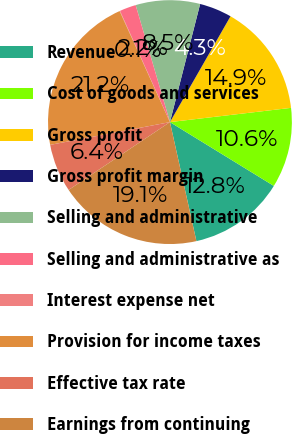Convert chart to OTSL. <chart><loc_0><loc_0><loc_500><loc_500><pie_chart><fcel>Revenue<fcel>Cost of goods and services<fcel>Gross profit<fcel>Gross profit margin<fcel>Selling and administrative<fcel>Selling and administrative as<fcel>Interest expense net<fcel>Provision for income taxes<fcel>Effective tax rate<fcel>Earnings from continuing<nl><fcel>12.75%<fcel>10.63%<fcel>14.86%<fcel>4.29%<fcel>8.52%<fcel>2.18%<fcel>0.06%<fcel>21.21%<fcel>6.4%<fcel>19.09%<nl></chart> 